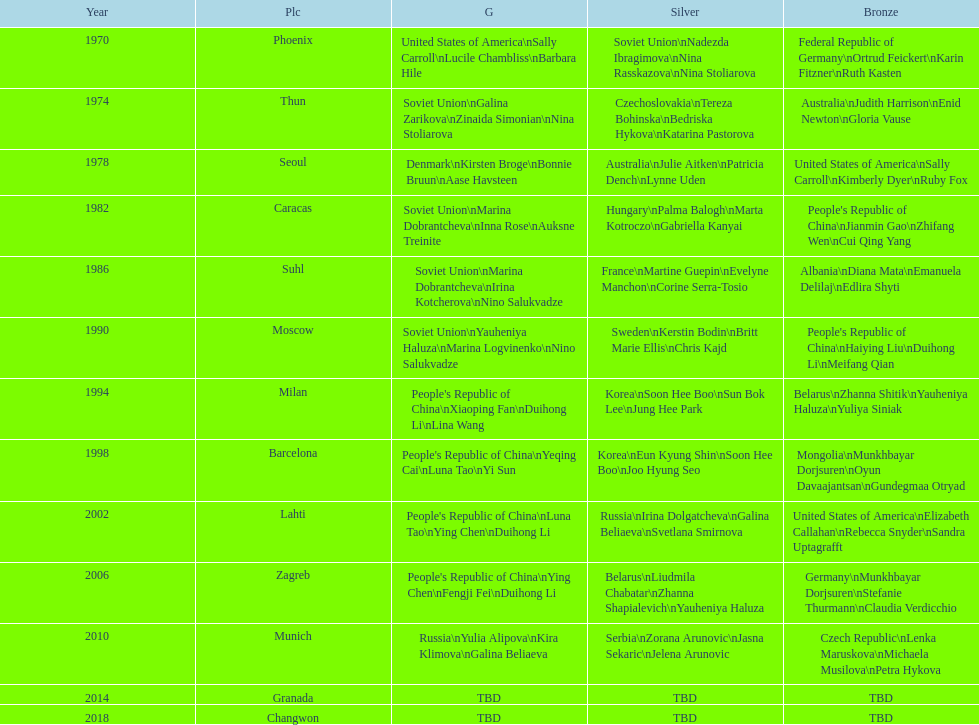Name one of the top three women to earn gold at the 1970 world championship held in phoenix, az Sally Carroll. 